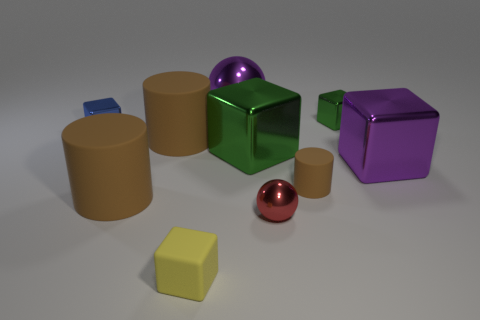How many green things have the same shape as the yellow thing?
Your answer should be very brief. 2. What is the shape of the red object?
Ensure brevity in your answer.  Sphere. Are there fewer small red spheres than blocks?
Give a very brief answer. Yes. Is there any other thing that has the same size as the blue thing?
Keep it short and to the point. Yes. There is another large object that is the same shape as the red metallic object; what is its material?
Offer a very short reply. Metal. Is the number of tiny balls greater than the number of matte cylinders?
Offer a terse response. No. How many other objects are there of the same color as the big ball?
Provide a short and direct response. 1. Is the material of the red ball the same as the cylinder right of the small metal ball?
Provide a succinct answer. No. There is a big brown matte cylinder behind the purple metal object right of the small green metal object; what number of large cubes are behind it?
Ensure brevity in your answer.  0. Are there fewer red spheres behind the blue thing than tiny cylinders in front of the small green object?
Keep it short and to the point. Yes. 